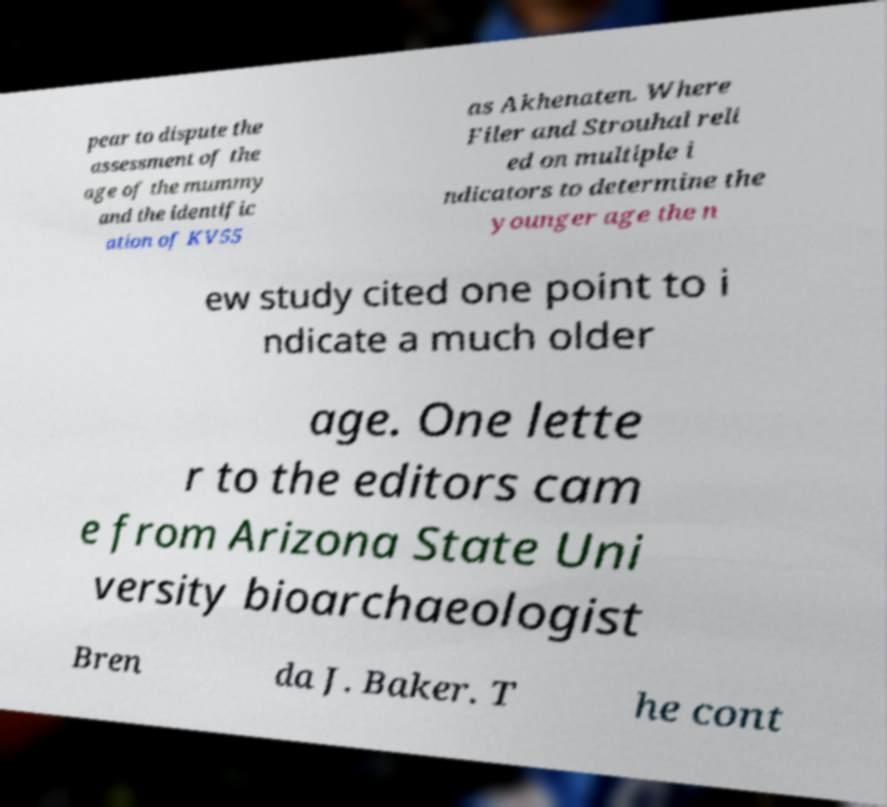Please read and relay the text visible in this image. What does it say? pear to dispute the assessment of the age of the mummy and the identific ation of KV55 as Akhenaten. Where Filer and Strouhal reli ed on multiple i ndicators to determine the younger age the n ew study cited one point to i ndicate a much older age. One lette r to the editors cam e from Arizona State Uni versity bioarchaeologist Bren da J. Baker. T he cont 